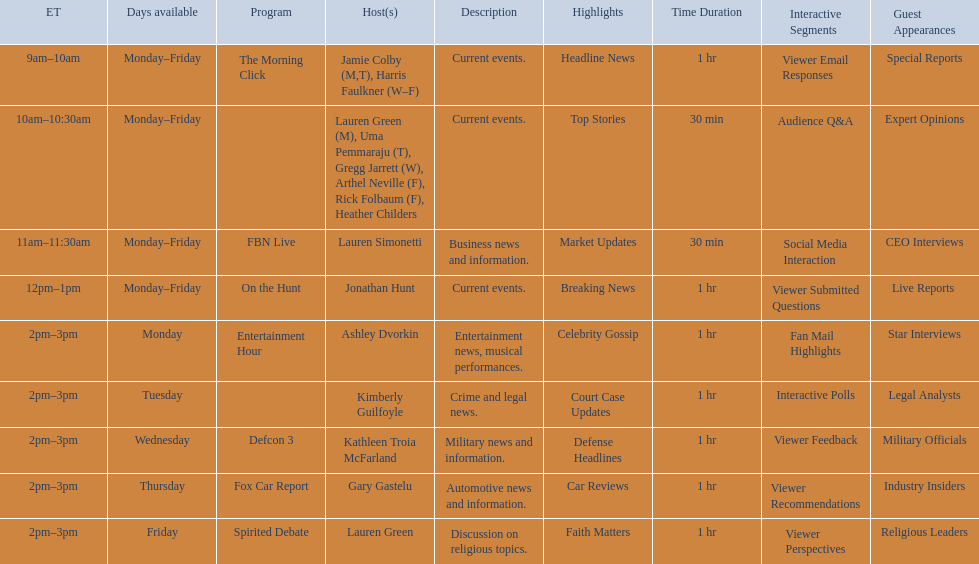Who are all of the hosts? Jamie Colby (M,T), Harris Faulkner (W–F), Lauren Green (M), Uma Pemmaraju (T), Gregg Jarrett (W), Arthel Neville (F), Rick Folbaum (F), Heather Childers, Lauren Simonetti, Jonathan Hunt, Ashley Dvorkin, Kimberly Guilfoyle, Kathleen Troia McFarland, Gary Gastelu, Lauren Green. Which hosts have shows on fridays? Jamie Colby (M,T), Harris Faulkner (W–F), Lauren Green (M), Uma Pemmaraju (T), Gregg Jarrett (W), Arthel Neville (F), Rick Folbaum (F), Heather Childers, Lauren Simonetti, Jonathan Hunt, Lauren Green. Of those, which host's show airs at 2pm? Lauren Green. 